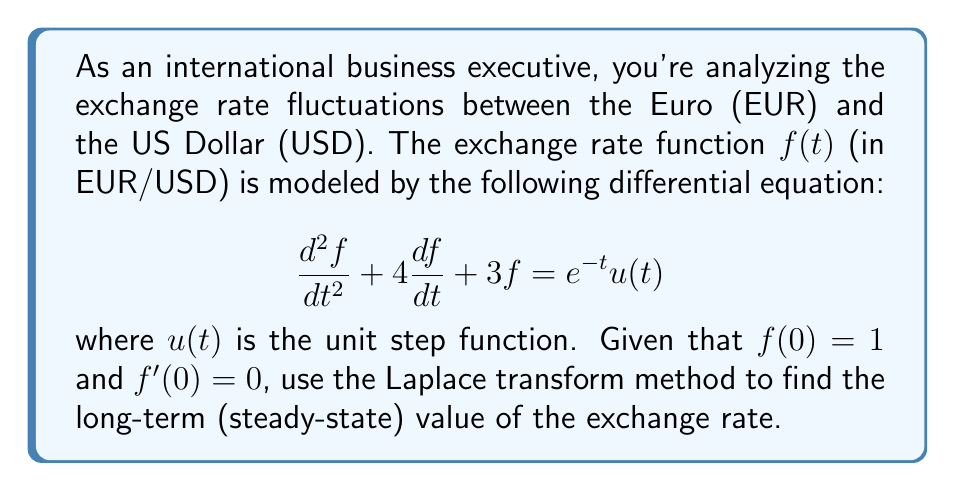Can you answer this question? Let's solve this problem step by step using the Laplace transform method:

1) First, we take the Laplace transform of both sides of the equation. Let $F(s)$ be the Laplace transform of $f(t)$:

   $$\mathcal{L}\{f''(t)\} + 4\mathcal{L}\{f'(t)\} + 3\mathcal{L}\{f(t)\} = \mathcal{L}\{e^{-t}u(t)\}$$

2) Using Laplace transform properties:

   $$[s^2F(s) - sf(0) - f'(0)] + 4[sF(s) - f(0)] + 3F(s) = \frac{1}{s+1}$$

3) Substituting the initial conditions $f(0) = 1$ and $f'(0) = 0$:

   $$s^2F(s) - s + 4sF(s) - 4 + 3F(s) = \frac{1}{s+1}$$

4) Simplifying:

   $$(s^2 + 4s + 3)F(s) = \frac{1}{s+1} + s + 4$$

5) Solving for $F(s)$:

   $$F(s) = \frac{1}{(s^2 + 4s + 3)(s+1)} + \frac{s + 4}{s^2 + 4s + 3}$$

6) To find the long-term (steady-state) value, we use the Final Value Theorem:

   $$\lim_{t \to \infty} f(t) = \lim_{s \to 0} sF(s)$$

7) Applying this to our $F(s)$:

   $$\lim_{s \to 0} s[\frac{1}{(s^2 + 4s + 3)(s+1)} + \frac{s + 4}{s^2 + 4s + 3}]$$

8) As $s \to 0$, the first term goes to zero, and we're left with:

   $$\lim_{s \to 0} \frac{s(s + 4)}{s^2 + 4s + 3} = \frac{0 + 4}{0 + 0 + 3} = \frac{4}{3}$$

Therefore, the long-term (steady-state) value of the exchange rate is $\frac{4}{3}$ EUR/USD.
Answer: $\frac{4}{3}$ EUR/USD 